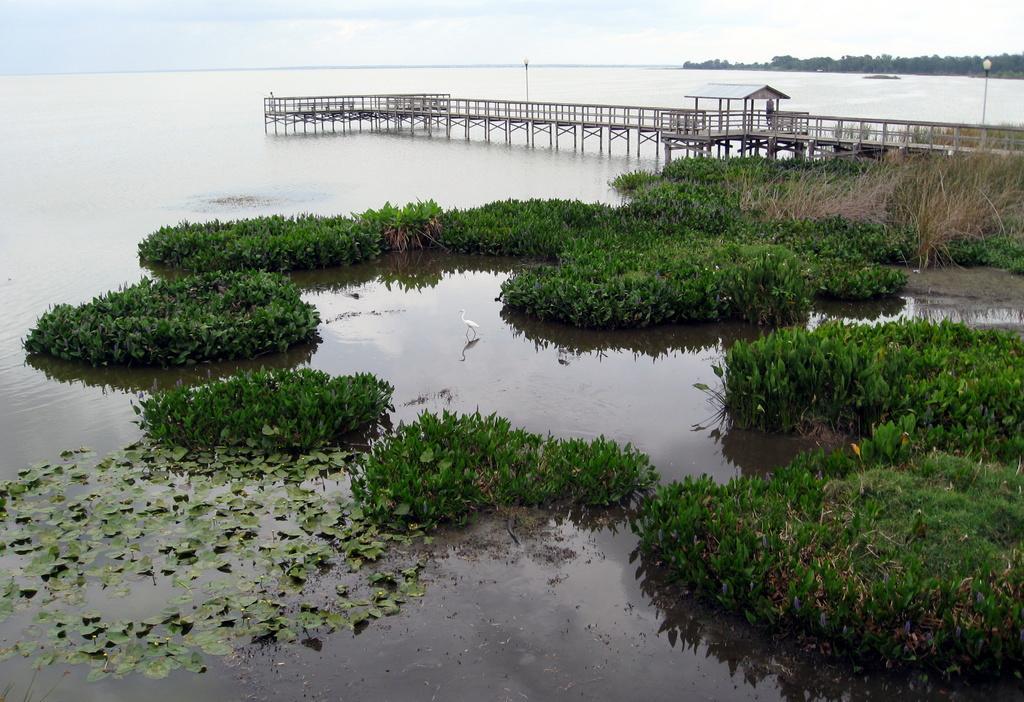Can you describe this image briefly? In this image there is a duck in the water and plants, leaves, there is a bridge on the river. In the background there are trees, few street lights and the sky. 